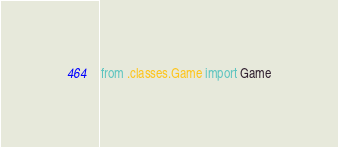Convert code to text. <code><loc_0><loc_0><loc_500><loc_500><_Python_>from .classes.Game import Game
</code> 